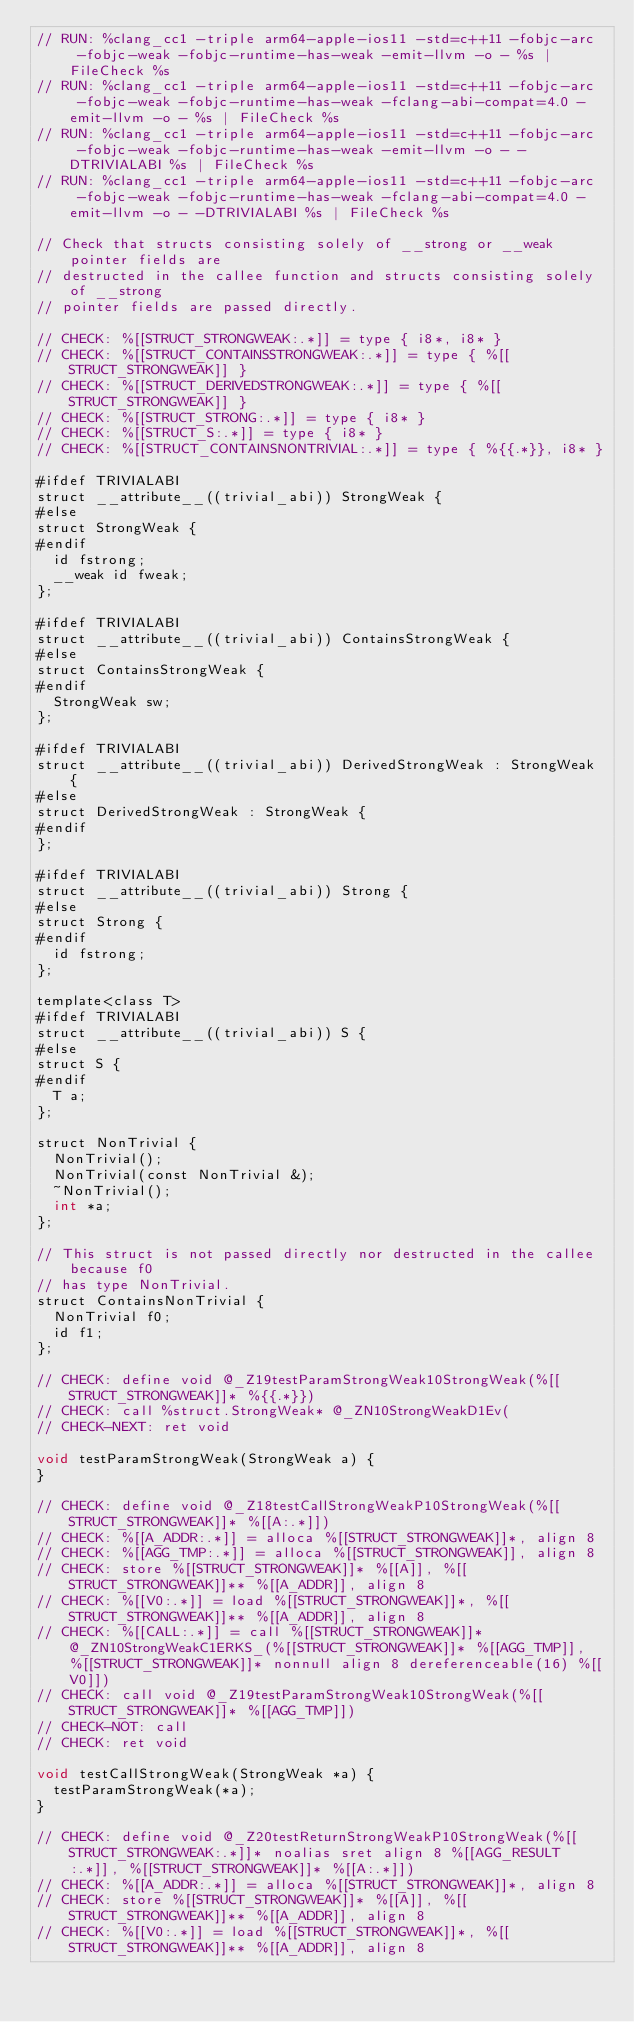Convert code to text. <code><loc_0><loc_0><loc_500><loc_500><_ObjectiveC_>// RUN: %clang_cc1 -triple arm64-apple-ios11 -std=c++11 -fobjc-arc  -fobjc-weak -fobjc-runtime-has-weak -emit-llvm -o - %s | FileCheck %s
// RUN: %clang_cc1 -triple arm64-apple-ios11 -std=c++11 -fobjc-arc  -fobjc-weak -fobjc-runtime-has-weak -fclang-abi-compat=4.0 -emit-llvm -o - %s | FileCheck %s
// RUN: %clang_cc1 -triple arm64-apple-ios11 -std=c++11 -fobjc-arc  -fobjc-weak -fobjc-runtime-has-weak -emit-llvm -o - -DTRIVIALABI %s | FileCheck %s
// RUN: %clang_cc1 -triple arm64-apple-ios11 -std=c++11 -fobjc-arc  -fobjc-weak -fobjc-runtime-has-weak -fclang-abi-compat=4.0 -emit-llvm -o - -DTRIVIALABI %s | FileCheck %s

// Check that structs consisting solely of __strong or __weak pointer fields are
// destructed in the callee function and structs consisting solely of __strong
// pointer fields are passed directly.

// CHECK: %[[STRUCT_STRONGWEAK:.*]] = type { i8*, i8* }
// CHECK: %[[STRUCT_CONTAINSSTRONGWEAK:.*]] = type { %[[STRUCT_STRONGWEAK]] }
// CHECK: %[[STRUCT_DERIVEDSTRONGWEAK:.*]] = type { %[[STRUCT_STRONGWEAK]] }
// CHECK: %[[STRUCT_STRONG:.*]] = type { i8* }
// CHECK: %[[STRUCT_S:.*]] = type { i8* }
// CHECK: %[[STRUCT_CONTAINSNONTRIVIAL:.*]] = type { %{{.*}}, i8* }

#ifdef TRIVIALABI
struct __attribute__((trivial_abi)) StrongWeak {
#else
struct StrongWeak {
#endif
  id fstrong;
  __weak id fweak;
};

#ifdef TRIVIALABI
struct __attribute__((trivial_abi)) ContainsStrongWeak {
#else
struct ContainsStrongWeak {
#endif
  StrongWeak sw;
};

#ifdef TRIVIALABI
struct __attribute__((trivial_abi)) DerivedStrongWeak : StrongWeak {
#else
struct DerivedStrongWeak : StrongWeak {
#endif
};

#ifdef TRIVIALABI
struct __attribute__((trivial_abi)) Strong {
#else
struct Strong {
#endif
  id fstrong;
};

template<class T>
#ifdef TRIVIALABI
struct __attribute__((trivial_abi)) S {
#else
struct S {
#endif
  T a;
};

struct NonTrivial {
  NonTrivial();
  NonTrivial(const NonTrivial &);
  ~NonTrivial();
  int *a;
};

// This struct is not passed directly nor destructed in the callee because f0
// has type NonTrivial.
struct ContainsNonTrivial {
  NonTrivial f0;
  id f1;
};

// CHECK: define void @_Z19testParamStrongWeak10StrongWeak(%[[STRUCT_STRONGWEAK]]* %{{.*}})
// CHECK: call %struct.StrongWeak* @_ZN10StrongWeakD1Ev(
// CHECK-NEXT: ret void

void testParamStrongWeak(StrongWeak a) {
}

// CHECK: define void @_Z18testCallStrongWeakP10StrongWeak(%[[STRUCT_STRONGWEAK]]* %[[A:.*]])
// CHECK: %[[A_ADDR:.*]] = alloca %[[STRUCT_STRONGWEAK]]*, align 8
// CHECK: %[[AGG_TMP:.*]] = alloca %[[STRUCT_STRONGWEAK]], align 8
// CHECK: store %[[STRUCT_STRONGWEAK]]* %[[A]], %[[STRUCT_STRONGWEAK]]** %[[A_ADDR]], align 8
// CHECK: %[[V0:.*]] = load %[[STRUCT_STRONGWEAK]]*, %[[STRUCT_STRONGWEAK]]** %[[A_ADDR]], align 8
// CHECK: %[[CALL:.*]] = call %[[STRUCT_STRONGWEAK]]* @_ZN10StrongWeakC1ERKS_(%[[STRUCT_STRONGWEAK]]* %[[AGG_TMP]], %[[STRUCT_STRONGWEAK]]* nonnull align 8 dereferenceable(16) %[[V0]])
// CHECK: call void @_Z19testParamStrongWeak10StrongWeak(%[[STRUCT_STRONGWEAK]]* %[[AGG_TMP]])
// CHECK-NOT: call
// CHECK: ret void

void testCallStrongWeak(StrongWeak *a) {
  testParamStrongWeak(*a);
}

// CHECK: define void @_Z20testReturnStrongWeakP10StrongWeak(%[[STRUCT_STRONGWEAK:.*]]* noalias sret align 8 %[[AGG_RESULT:.*]], %[[STRUCT_STRONGWEAK]]* %[[A:.*]])
// CHECK: %[[A_ADDR:.*]] = alloca %[[STRUCT_STRONGWEAK]]*, align 8
// CHECK: store %[[STRUCT_STRONGWEAK]]* %[[A]], %[[STRUCT_STRONGWEAK]]** %[[A_ADDR]], align 8
// CHECK: %[[V0:.*]] = load %[[STRUCT_STRONGWEAK]]*, %[[STRUCT_STRONGWEAK]]** %[[A_ADDR]], align 8</code> 